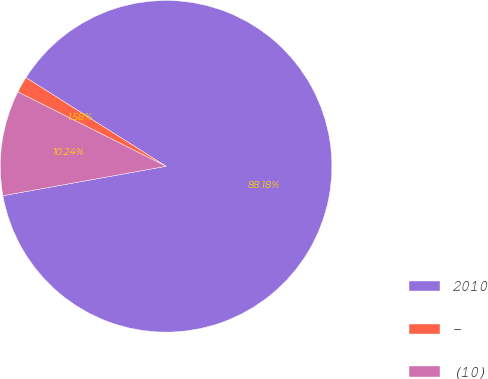<chart> <loc_0><loc_0><loc_500><loc_500><pie_chart><fcel>2010<fcel>-<fcel>(10)<nl><fcel>88.18%<fcel>1.58%<fcel>10.24%<nl></chart> 